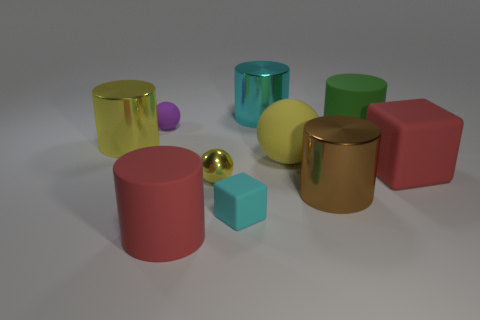What is the shape of the object that is the same color as the big matte cube?
Offer a very short reply. Cylinder. Are there any other things that are the same color as the small matte sphere?
Your answer should be very brief. No. There is a cylinder behind the purple matte thing; what is its size?
Keep it short and to the point. Large. What material is the small cyan block?
Your answer should be very brief. Rubber. There is a red thing that is the same shape as the big green rubber thing; what is its material?
Keep it short and to the point. Rubber. Is the number of large yellow rubber things to the right of the big yellow rubber thing greater than the number of large green rubber cylinders behind the large green matte object?
Make the answer very short. No. What is the shape of the big green thing that is made of the same material as the red cylinder?
Offer a terse response. Cylinder. There is a sphere that is in front of the big green cylinder and behind the small shiny ball; what is its material?
Provide a short and direct response. Rubber. Is the size of the red matte block the same as the purple rubber object?
Your answer should be very brief. No. What shape is the brown thing that is the same size as the cyan cylinder?
Offer a terse response. Cylinder. 